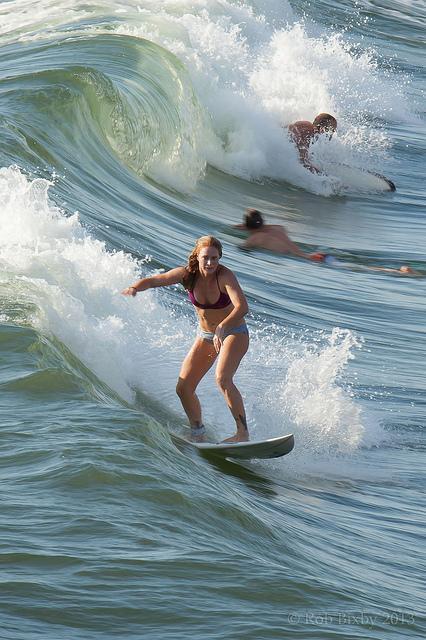How many people are in the picture?
Give a very brief answer. 2. 